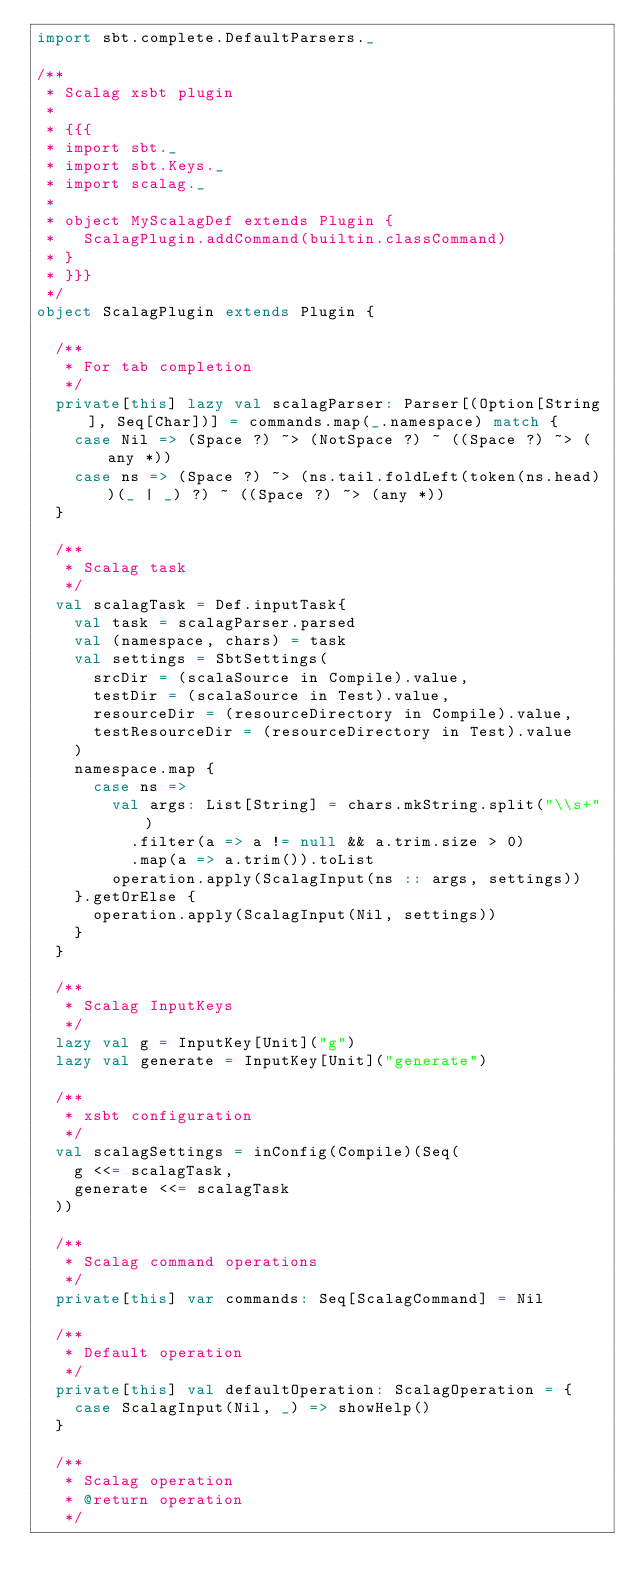<code> <loc_0><loc_0><loc_500><loc_500><_Scala_>import sbt.complete.DefaultParsers._

/**
 * Scalag xsbt plugin
 *
 * {{{
 * import sbt._
 * import sbt.Keys._
 * import scalag._
 *
 * object MyScalagDef extends Plugin {
 *   ScalagPlugin.addCommand(builtin.classCommand)
 * }
 * }}}
 */
object ScalagPlugin extends Plugin {

  /**
   * For tab completion
   */
  private[this] lazy val scalagParser: Parser[(Option[String], Seq[Char])] = commands.map(_.namespace) match {
    case Nil => (Space ?) ~> (NotSpace ?) ~ ((Space ?) ~> (any *))
    case ns => (Space ?) ~> (ns.tail.foldLeft(token(ns.head))(_ | _) ?) ~ ((Space ?) ~> (any *))
  }

  /**
   * Scalag task
   */
  val scalagTask = Def.inputTask{
    val task = scalagParser.parsed
    val (namespace, chars) = task
    val settings = SbtSettings(
      srcDir = (scalaSource in Compile).value,
      testDir = (scalaSource in Test).value,
      resourceDir = (resourceDirectory in Compile).value,
      testResourceDir = (resourceDirectory in Test).value
    )
    namespace.map {
      case ns =>
        val args: List[String] = chars.mkString.split("\\s+")
          .filter(a => a != null && a.trim.size > 0)
          .map(a => a.trim()).toList
        operation.apply(ScalagInput(ns :: args, settings))
    }.getOrElse {
      operation.apply(ScalagInput(Nil, settings))
    }
  }

  /**
   * Scalag InputKeys
   */
  lazy val g = InputKey[Unit]("g")
  lazy val generate = InputKey[Unit]("generate")

  /**
   * xsbt configuration
   */
  val scalagSettings = inConfig(Compile)(Seq(
    g <<= scalagTask,
    generate <<= scalagTask
  ))

  /**
   * Scalag command operations
   */
  private[this] var commands: Seq[ScalagCommand] = Nil

  /**
   * Default operation
   */
  private[this] val defaultOperation: ScalagOperation = {
    case ScalagInput(Nil, _) => showHelp()
  }

  /**
   * Scalag operation
   * @return operation
   */</code> 